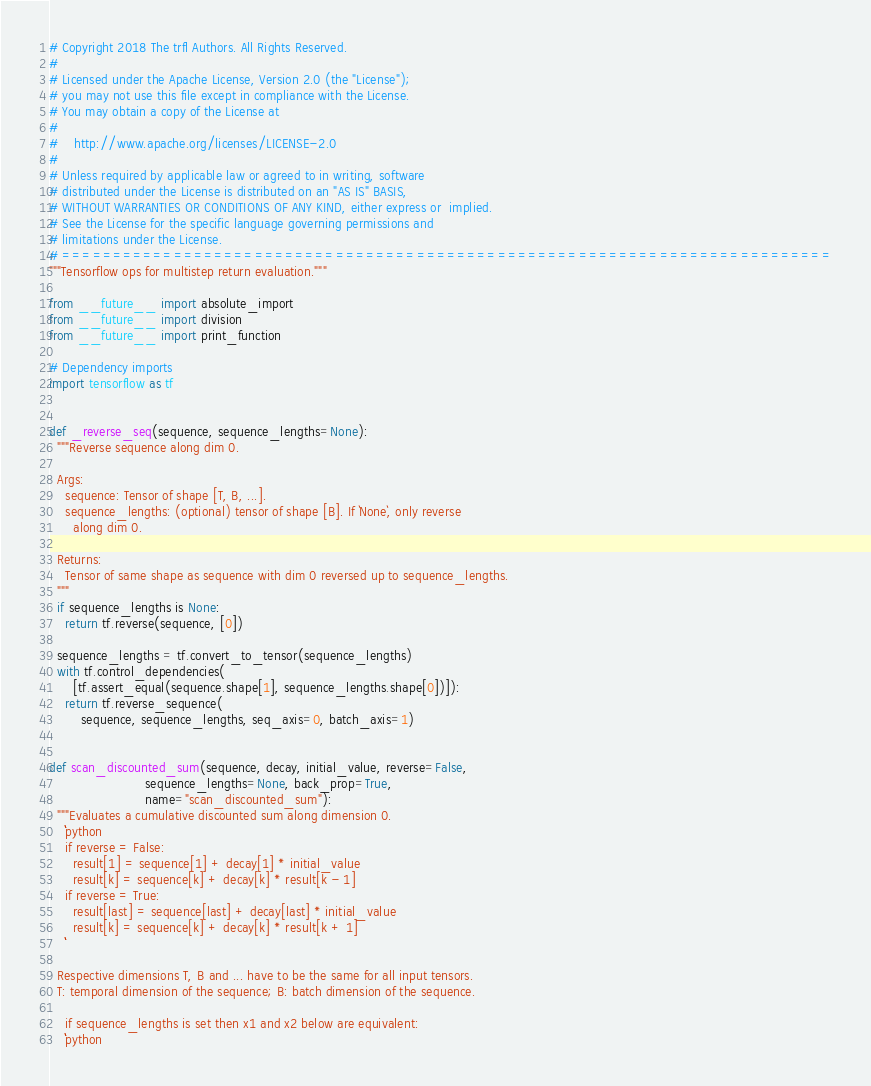<code> <loc_0><loc_0><loc_500><loc_500><_Python_># Copyright 2018 The trfl Authors. All Rights Reserved.
#
# Licensed under the Apache License, Version 2.0 (the "License");
# you may not use this file except in compliance with the License.
# You may obtain a copy of the License at
#
#    http://www.apache.org/licenses/LICENSE-2.0
#
# Unless required by applicable law or agreed to in writing, software
# distributed under the License is distributed on an "AS IS" BASIS,
# WITHOUT WARRANTIES OR CONDITIONS OF ANY KIND, either express or  implied.
# See the License for the specific language governing permissions and
# limitations under the License.
# ============================================================================
"""Tensorflow ops for multistep return evaluation."""

from __future__ import absolute_import
from __future__ import division
from __future__ import print_function

# Dependency imports
import tensorflow as tf


def _reverse_seq(sequence, sequence_lengths=None):
  """Reverse sequence along dim 0.

  Args:
    sequence: Tensor of shape [T, B, ...].
    sequence_lengths: (optional) tensor of shape [B]. If `None`, only reverse
      along dim 0.

  Returns:
    Tensor of same shape as sequence with dim 0 reversed up to sequence_lengths.
  """
  if sequence_lengths is None:
    return tf.reverse(sequence, [0])

  sequence_lengths = tf.convert_to_tensor(sequence_lengths)
  with tf.control_dependencies(
      [tf.assert_equal(sequence.shape[1], sequence_lengths.shape[0])]):
    return tf.reverse_sequence(
        sequence, sequence_lengths, seq_axis=0, batch_axis=1)


def scan_discounted_sum(sequence, decay, initial_value, reverse=False,
                        sequence_lengths=None, back_prop=True,
                        name="scan_discounted_sum"):
  """Evaluates a cumulative discounted sum along dimension 0.
    ```python
    if reverse = False:
      result[1] = sequence[1] + decay[1] * initial_value
      result[k] = sequence[k] + decay[k] * result[k - 1]
    if reverse = True:
      result[last] = sequence[last] + decay[last] * initial_value
      result[k] = sequence[k] + decay[k] * result[k + 1]
    ```

  Respective dimensions T, B and ... have to be the same for all input tensors.
  T: temporal dimension of the sequence; B: batch dimension of the sequence.

    if sequence_lengths is set then x1 and x2 below are equivalent:
    ```python</code> 